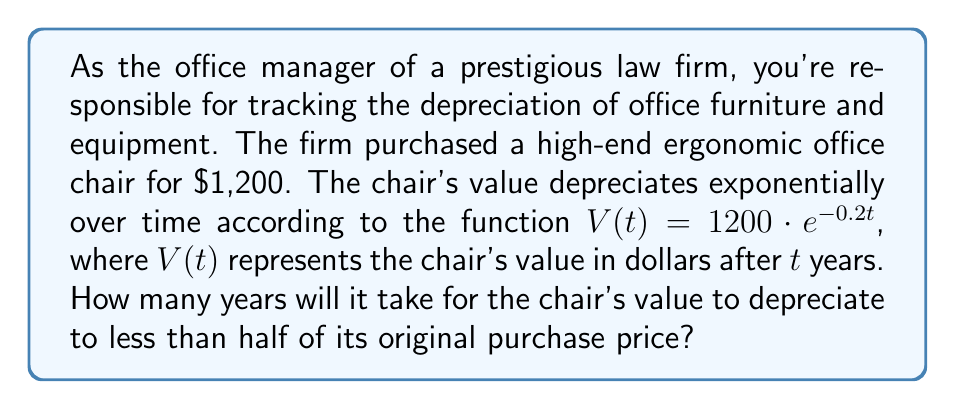Show me your answer to this math problem. To solve this problem, we need to follow these steps:

1) We want to find when the chair's value is less than half of its original price. The original price is $1,200, so we're looking for when V(t) < $600.

2) We can set up the inequality:
   $1200 \cdot e^{-0.2t} < 600$

3) Divide both sides by 1200:
   $e^{-0.2t} < 0.5$

4) Take the natural log of both sides:
   $\ln(e^{-0.2t}) < \ln(0.5)$

5) Simplify the left side using the properties of logarithms:
   $-0.2t < \ln(0.5)$

6) Divide both sides by -0.2:
   $t > -\frac{\ln(0.5)}{0.2}$

7) Calculate the right side:
   $t > -\frac{-0.693147}{0.2} \approx 3.46574$

8) Since we're asked for the number of years and we need the value to be strictly less than half, we round up to the next whole number.

Therefore, it will take 4 years for the chair's value to depreciate to less than half of its original purchase price.
Answer: 4 years 